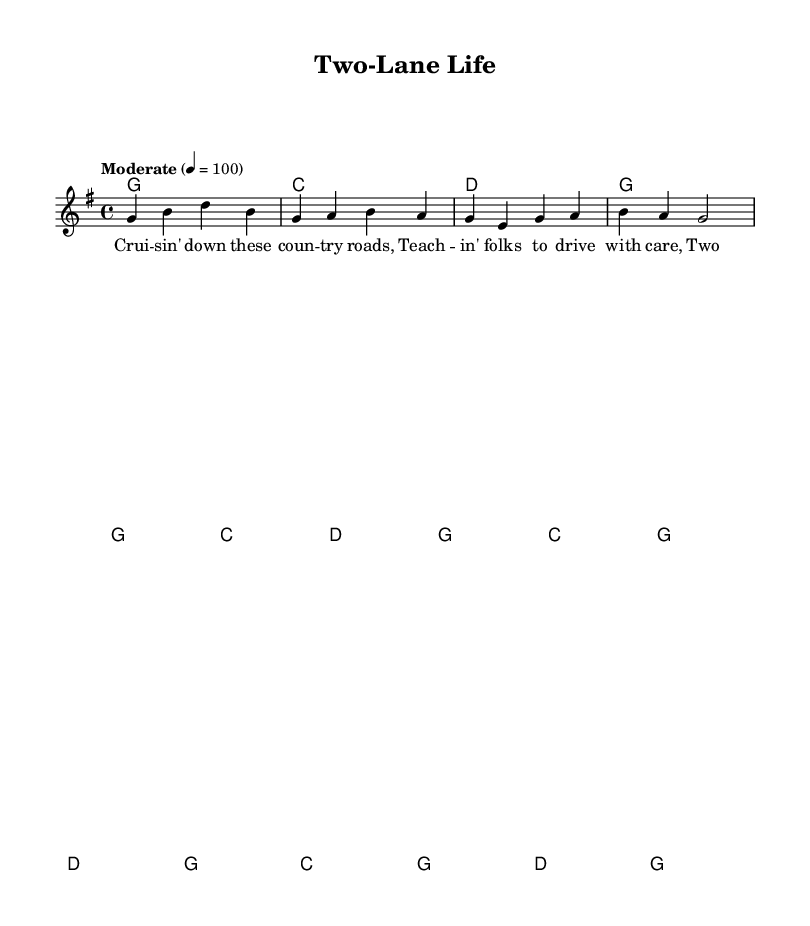What is the key signature of this music? The key signature is G major, which has one sharp (F#).
Answer: G major What is the time signature of the music? The time signature is 4/4, meaning there are four beats in each measure.
Answer: 4/4 What is the tempo marking for this piece? The tempo marking given in the sheet music is "Moderate" set to a quarter note equals 100 beats per minute.
Answer: Moderate How many measures does the verse section contain? The verse section consists of 8 measures, as indicated by the layout of the included chords.
Answer: 8 measures Identify the primary theme of the lyrics provided in this sheet music. The primary theme of the lyrics revolves around the experiences and feelings associated with driving and life in a small town, reflecting a simple and bold lifestyle.
Answer: Driving and small-town life What is the chord progression for the chorus section? The chord progression for the chorus is C, G, D, G, which represents a common sequence in country music that emphasizes the root and dominant chords.
Answer: C, G, D, G How does the melody relate to the lyrics in this piece? The melody matches the phrasing of the lyrics, creating a musical expression that reflects the storytelling nature typical of country music, allowing for emotional engagement with the narrative about driving and life.
Answer: Reflects storytelling 